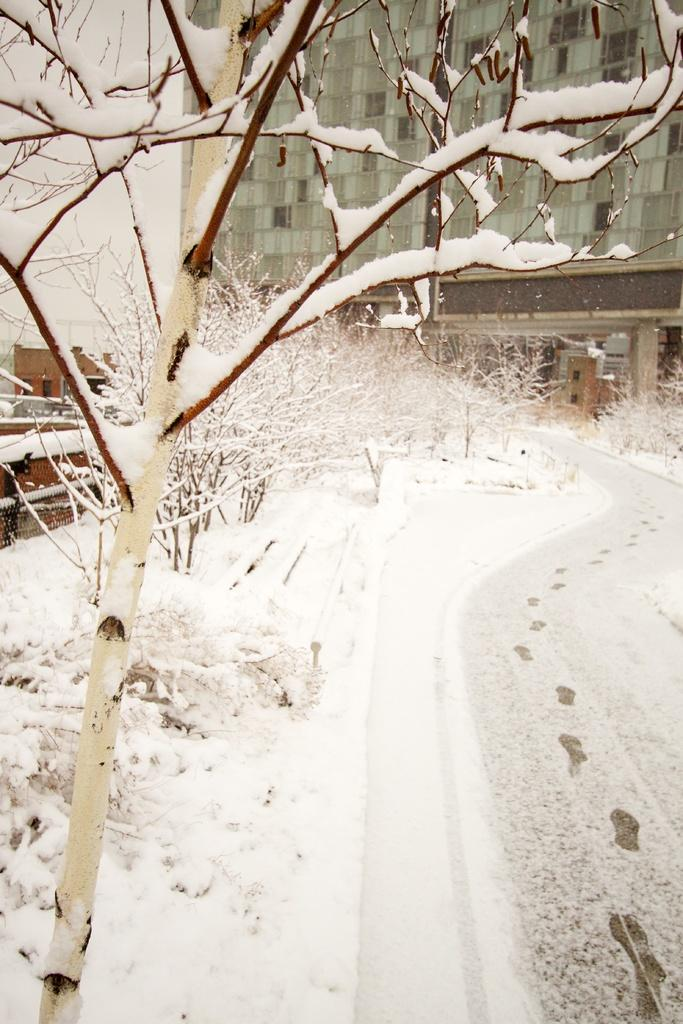What is the primary feature of the image? The primary feature of the image is the snow. Where is the snow located in the image? The snow is on the trees. What is visible at the bottom of the image? There is a road at the bottom of the image. What can be seen in the background of the image? There is a building in the background of the image. What type of book can be seen on the plate in the image? There is no book or plate present in the image; it features snow on trees, a road, and a building in the background. 